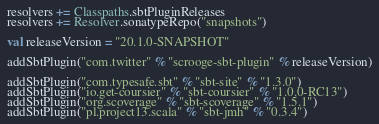<code> <loc_0><loc_0><loc_500><loc_500><_Scala_>resolvers += Classpaths.sbtPluginReleases
resolvers += Resolver.sonatypeRepo("snapshots")

val releaseVersion = "20.1.0-SNAPSHOT"

addSbtPlugin("com.twitter" % "scrooge-sbt-plugin" % releaseVersion)

addSbtPlugin("com.typesafe.sbt" % "sbt-site" % "1.3.0")
addSbtPlugin("io.get-coursier" % "sbt-coursier" % "1.0.0-RC13")
addSbtPlugin("org.scoverage" % "sbt-scoverage" % "1.5.1")
addSbtPlugin("pl.project13.scala" % "sbt-jmh" % "0.3.4")
</code> 